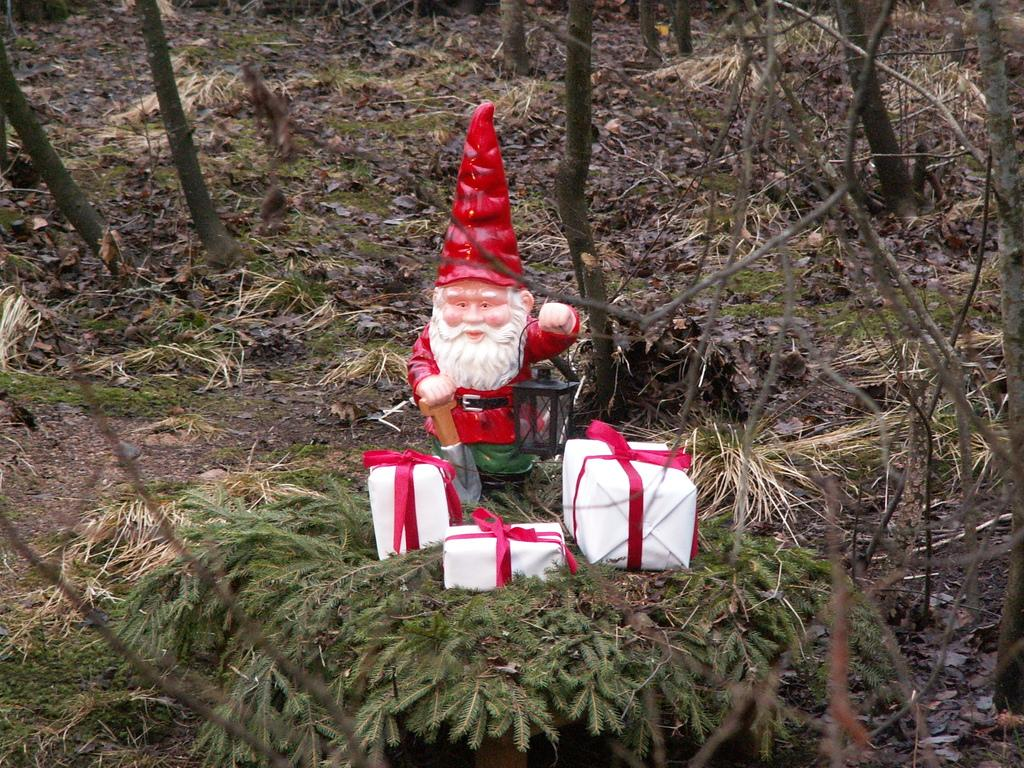What type of living organisms can be seen in the image? Plants are visible in the image. What is the surface on which the plants are growing? The ground is visible in the image. What else can be seen in the image besides plants? There are branches, boxes, ribbons, and a toy in the image. What is the toy holding in the image? The toy is holding a lantern. What is the toy using to hold the lantern? There is an object being held by the toy, which is likely a handle or similar feature. How many dust particles can be seen floating in the image? There is no mention of dust particles in the image, so it is not possible to determine their number. What is the wish associated with the plants in the image? There is no mention of a wish or any related context in the image. 